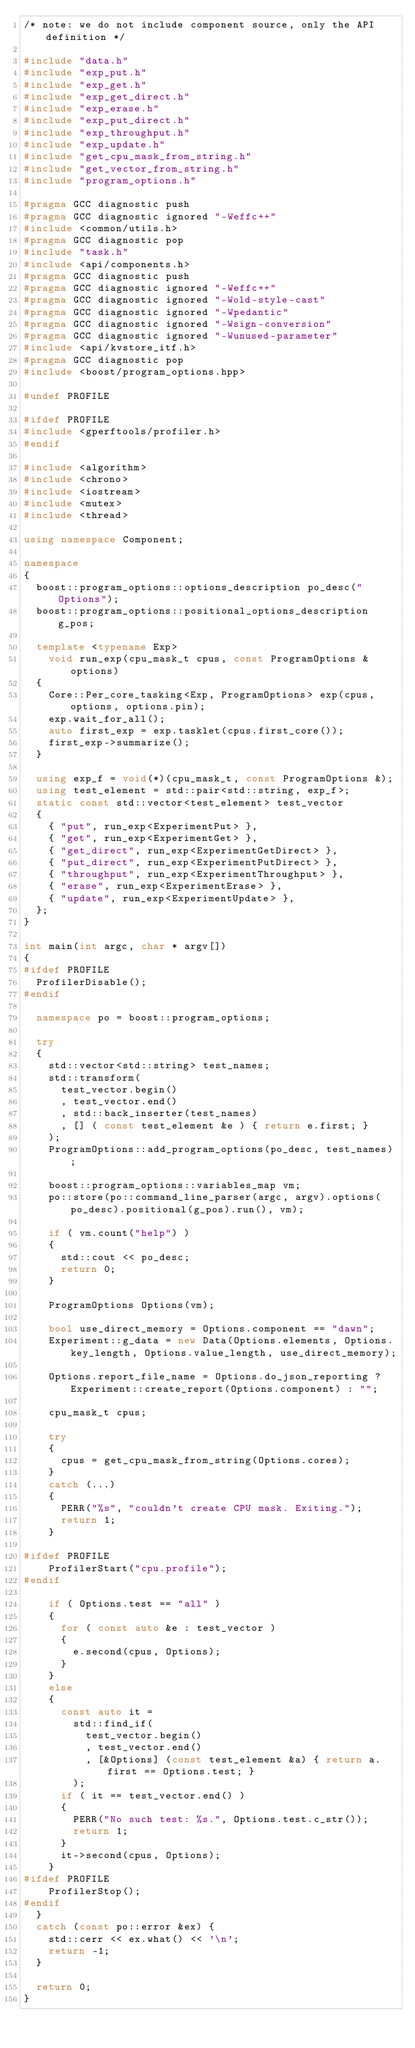<code> <loc_0><loc_0><loc_500><loc_500><_C++_>/* note: we do not include component source, only the API definition */

#include "data.h"
#include "exp_put.h"
#include "exp_get.h"
#include "exp_get_direct.h"
#include "exp_erase.h"
#include "exp_put_direct.h"
#include "exp_throughput.h"
#include "exp_update.h"
#include "get_cpu_mask_from_string.h"
#include "get_vector_from_string.h"
#include "program_options.h"

#pragma GCC diagnostic push
#pragma GCC diagnostic ignored "-Weffc++"
#include <common/utils.h>
#pragma GCC diagnostic pop
#include "task.h"
#include <api/components.h>
#pragma GCC diagnostic push
#pragma GCC diagnostic ignored "-Weffc++"
#pragma GCC diagnostic ignored "-Wold-style-cast"
#pragma GCC diagnostic ignored "-Wpedantic"
#pragma GCC diagnostic ignored "-Wsign-conversion"
#pragma GCC diagnostic ignored "-Wunused-parameter"
#include <api/kvstore_itf.h>
#pragma GCC diagnostic pop
#include <boost/program_options.hpp>

#undef PROFILE

#ifdef PROFILE
#include <gperftools/profiler.h>
#endif

#include <algorithm>
#include <chrono>
#include <iostream>
#include <mutex>
#include <thread>

using namespace Component;

namespace
{
  boost::program_options::options_description po_desc("Options");
  boost::program_options::positional_options_description g_pos;

  template <typename Exp>
    void run_exp(cpu_mask_t cpus, const ProgramOptions &options)
  {
    Core::Per_core_tasking<Exp, ProgramOptions> exp(cpus, options, options.pin);
    exp.wait_for_all();
    auto first_exp = exp.tasklet(cpus.first_core());
    first_exp->summarize();
  }

  using exp_f = void(*)(cpu_mask_t, const ProgramOptions &);
  using test_element = std::pair<std::string, exp_f>;
  static const std::vector<test_element> test_vector
  {
    { "put", run_exp<ExperimentPut> },
    { "get", run_exp<ExperimentGet> },
    { "get_direct", run_exp<ExperimentGetDirect> },
    { "put_direct", run_exp<ExperimentPutDirect> },
    { "throughput", run_exp<ExperimentThroughput> },
    { "erase", run_exp<ExperimentErase> },
    { "update", run_exp<ExperimentUpdate> },
  };
}

int main(int argc, char * argv[])
{
#ifdef PROFILE
  ProfilerDisable();
#endif

  namespace po = boost::program_options; 

  try
  {
    std::vector<std::string> test_names;
    std::transform(
      test_vector.begin()
      , test_vector.end()
      , std::back_inserter(test_names)
      , [] ( const test_element &e ) { return e.first; }
    );
    ProgramOptions::add_program_options(po_desc, test_names);

    boost::program_options::variables_map vm; 
    po::store(po::command_line_parser(argc, argv).options(po_desc).positional(g_pos).run(), vm);

    if ( vm.count("help") )
    {
      std::cout << po_desc;
      return 0;
    }

    ProgramOptions Options(vm);

    bool use_direct_memory = Options.component == "dawn";
    Experiment::g_data = new Data(Options.elements, Options.key_length, Options.value_length, use_direct_memory);

    Options.report_file_name = Options.do_json_reporting ? Experiment::create_report(Options.component) : "";

    cpu_mask_t cpus;

    try
    {
      cpus = get_cpu_mask_from_string(Options.cores);
    }
    catch (...)
    {
      PERR("%s", "couldn't create CPU mask. Exiting.");
      return 1;
    }

#ifdef PROFILE
    ProfilerStart("cpu.profile");
#endif

    if ( Options.test == "all" )
    {
      for ( const auto &e : test_vector )
      {
        e.second(cpus, Options);
      }
    }
    else
    {
      const auto it =
        std::find_if(
          test_vector.begin()
          , test_vector.end()
          , [&Options] (const test_element &a) { return a.first == Options.test; }
        );
      if ( it == test_vector.end() )
      {
        PERR("No such test: %s.", Options.test.c_str());
        return 1;
      }
      it->second(cpus, Options);
    }
#ifdef PROFILE
    ProfilerStop();
#endif
  }
  catch (const po::error &ex) {
    std::cerr << ex.what() << '\n';
    return -1;
  }
  
  return 0;
}
</code> 